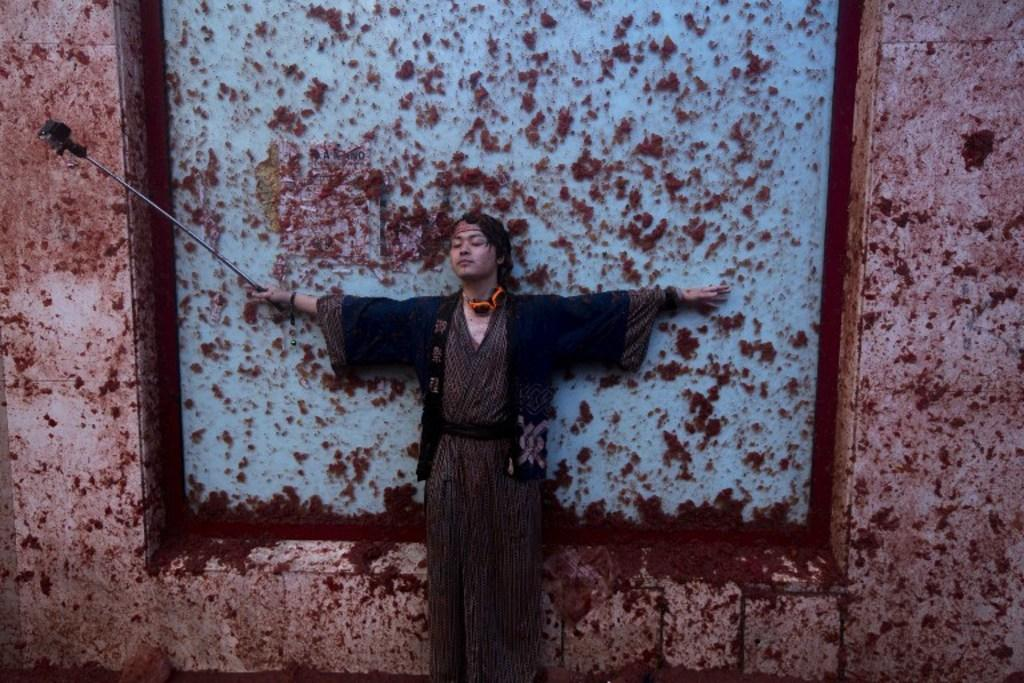Who is the main subject in the image? There is a man in the image. What is the man wearing? The man is wearing a fancy dress. What object is the man holding in his hand? The man is holding a stick in his hand. What can be seen in the background of the image? There is a wall in the background of the image. What type of agreement is the man signing in the image? There is no indication in the image that the man is signing any agreement; he is holding a stick instead. 